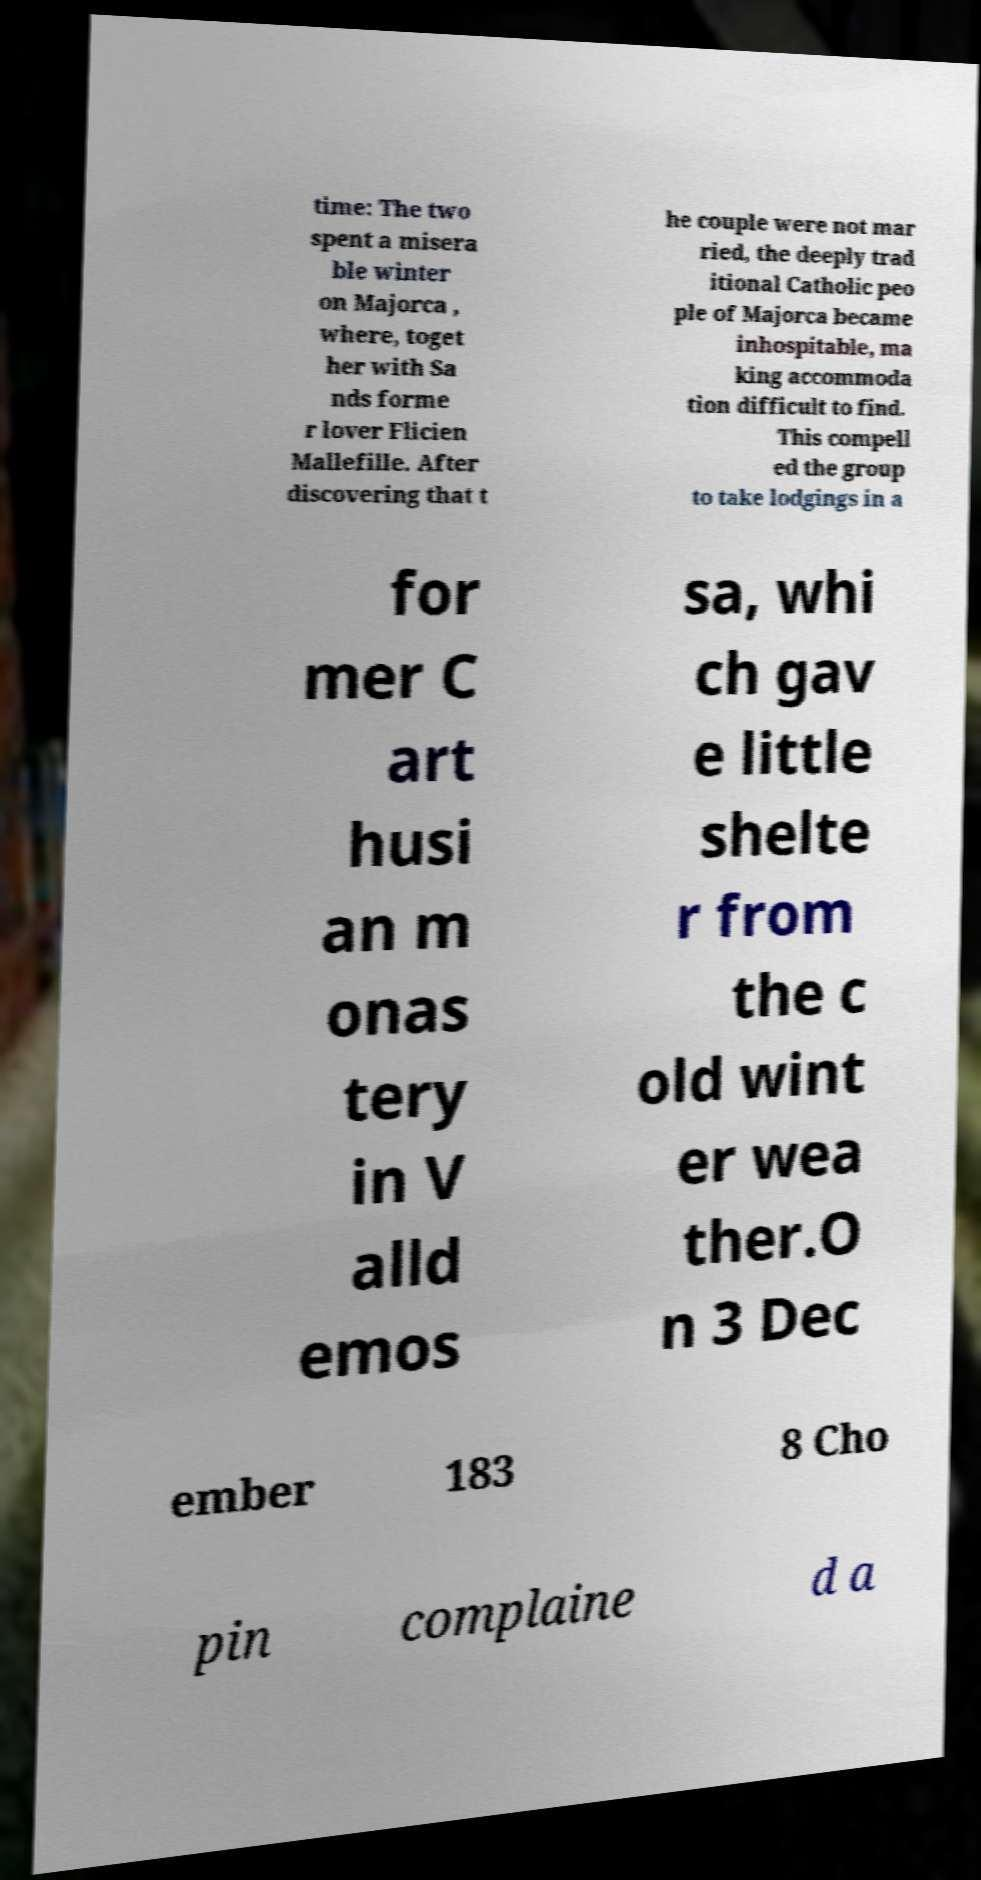Can you read and provide the text displayed in the image?This photo seems to have some interesting text. Can you extract and type it out for me? time: The two spent a misera ble winter on Majorca , where, toget her with Sa nds forme r lover Flicien Mallefille. After discovering that t he couple were not mar ried, the deeply trad itional Catholic peo ple of Majorca became inhospitable, ma king accommoda tion difficult to find. This compell ed the group to take lodgings in a for mer C art husi an m onas tery in V alld emos sa, whi ch gav e little shelte r from the c old wint er wea ther.O n 3 Dec ember 183 8 Cho pin complaine d a 